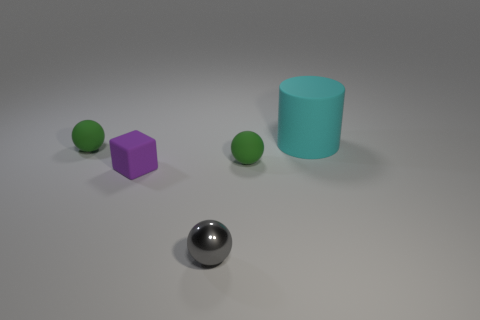Is there anything else that is the same size as the cyan object?
Your answer should be very brief. No. Are there more big purple spheres than tiny spheres?
Your answer should be compact. No. There is a tiny sphere that is to the left of the shiny ball; does it have the same color as the small metallic object?
Provide a short and direct response. No. What number of objects are rubber objects on the left side of the cyan cylinder or small green objects that are behind the small gray metallic sphere?
Your response must be concise. 3. How many things are behind the gray ball and right of the small purple cube?
Offer a very short reply. 2. Is the material of the tiny purple block the same as the cylinder?
Your answer should be compact. Yes. What is the shape of the thing that is right of the green rubber sphere to the right of the small rubber sphere to the left of the tiny purple object?
Ensure brevity in your answer.  Cylinder. What is the material of the thing that is right of the tiny metal thing and to the left of the big matte thing?
Provide a succinct answer. Rubber. There is a small rubber sphere on the right side of the green ball that is behind the green rubber object to the right of the tiny block; what color is it?
Ensure brevity in your answer.  Green. What number of purple objects are big cylinders or tiny cubes?
Offer a terse response. 1. 